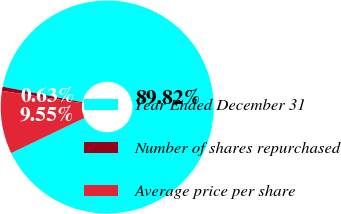<chart> <loc_0><loc_0><loc_500><loc_500><pie_chart><fcel>Year Ended December 31<fcel>Number of shares repurchased<fcel>Average price per share<nl><fcel>89.82%<fcel>0.63%<fcel>9.55%<nl></chart> 